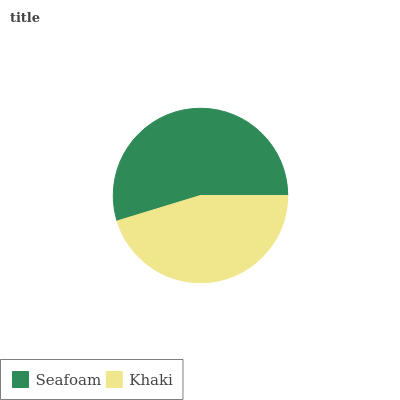Is Khaki the minimum?
Answer yes or no. Yes. Is Seafoam the maximum?
Answer yes or no. Yes. Is Khaki the maximum?
Answer yes or no. No. Is Seafoam greater than Khaki?
Answer yes or no. Yes. Is Khaki less than Seafoam?
Answer yes or no. Yes. Is Khaki greater than Seafoam?
Answer yes or no. No. Is Seafoam less than Khaki?
Answer yes or no. No. Is Seafoam the high median?
Answer yes or no. Yes. Is Khaki the low median?
Answer yes or no. Yes. Is Khaki the high median?
Answer yes or no. No. Is Seafoam the low median?
Answer yes or no. No. 